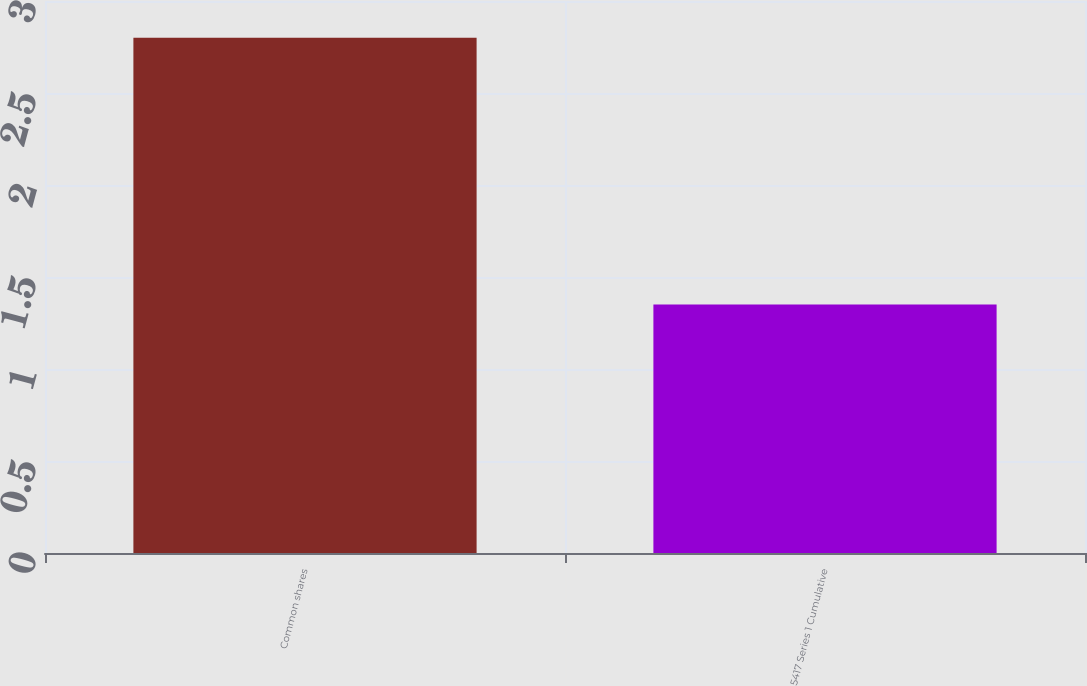Convert chart. <chart><loc_0><loc_0><loc_500><loc_500><bar_chart><fcel>Common shares<fcel>5417 Series 1 Cumulative<nl><fcel>2.8<fcel>1.35<nl></chart> 